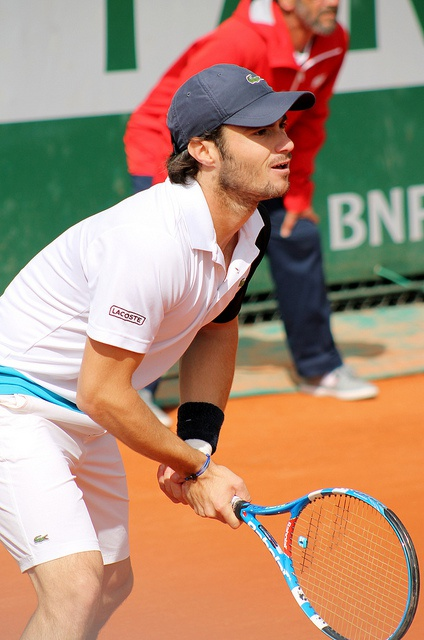Describe the objects in this image and their specific colors. I can see people in darkgray, white, tan, and salmon tones, people in darkgray, black, salmon, maroon, and red tones, and tennis racket in darkgray, orange, salmon, and red tones in this image. 